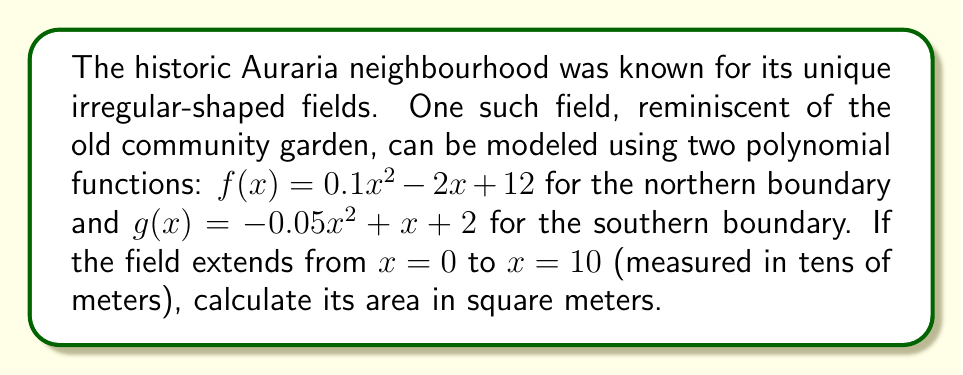Help me with this question. To calculate the area of the field, we need to find the area between the two curves $f(x)$ and $g(x)$ from $x = 0$ to $x = 10$. This can be done using definite integration.

Step 1: Set up the integral
The area is given by:
$$A = \int_0^{10} [f(x) - g(x)] dx$$

Step 2: Substitute the functions
$$A = \int_0^{10} [(0.1x^2 - 2x + 12) - (-0.05x^2 + x + 2)] dx$$

Step 3: Simplify the integrand
$$A = \int_0^{10} (0.15x^2 - 3x + 10) dx$$

Step 4: Integrate
$$A = [0.05x^3 - 1.5x^2 + 10x]_0^{10}$$

Step 5: Evaluate the integral
$$A = (0.05(10^3) - 1.5(10^2) + 10(10)) - (0.05(0^3) - 1.5(0^2) + 10(0))$$
$$A = (50 - 150 + 100) - 0$$
$$A = 0$$

Step 6: Convert to square meters
Since x was measured in tens of meters, we need to multiply our result by 100 to get square meters:
$$A = 0 \times 100 = 0 \text{ m}^2$$
Answer: $0 \text{ m}^2$ 